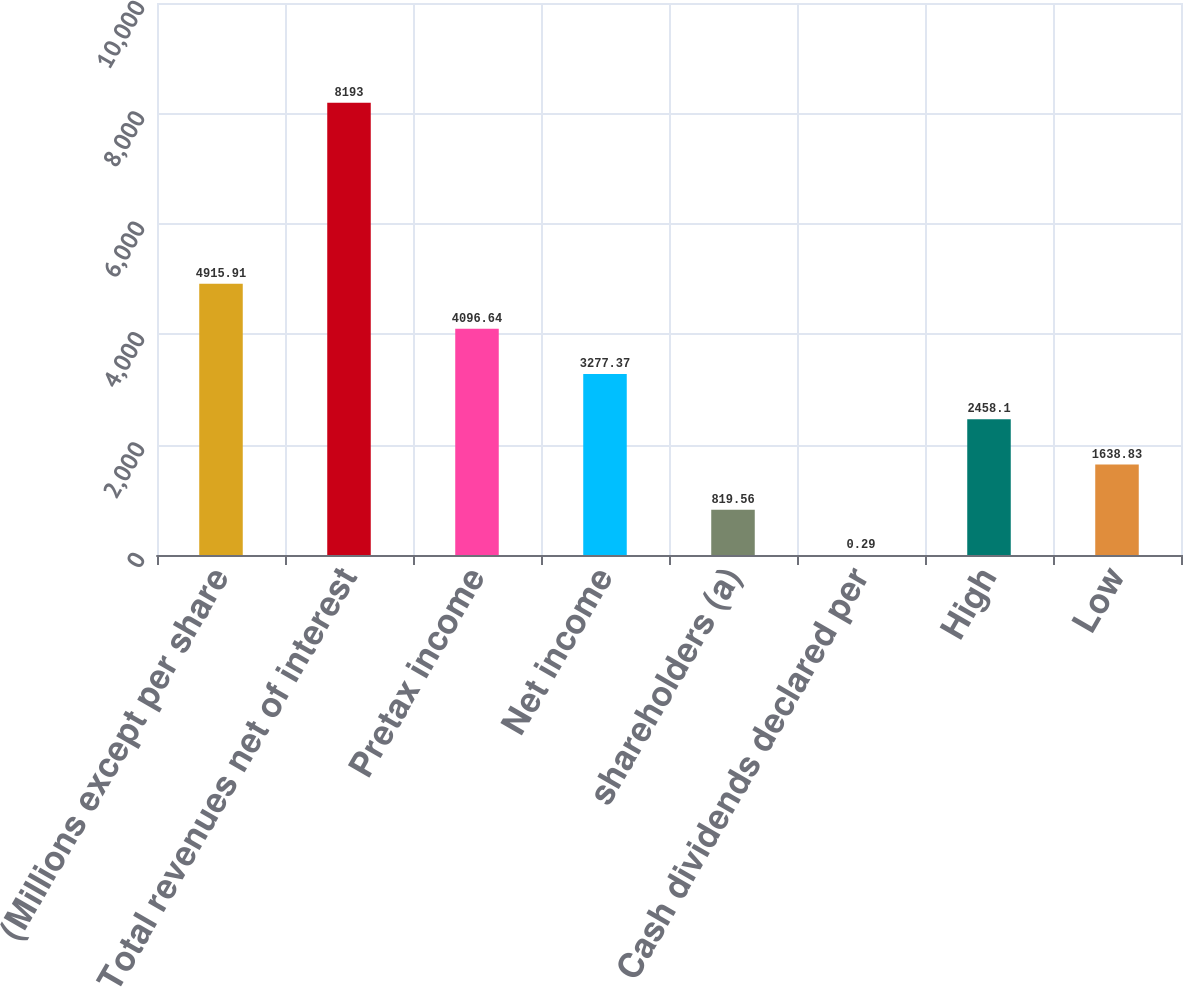<chart> <loc_0><loc_0><loc_500><loc_500><bar_chart><fcel>(Millions except per share<fcel>Total revenues net of interest<fcel>Pretax income<fcel>Net income<fcel>shareholders (a)<fcel>Cash dividends declared per<fcel>High<fcel>Low<nl><fcel>4915.91<fcel>8193<fcel>4096.64<fcel>3277.37<fcel>819.56<fcel>0.29<fcel>2458.1<fcel>1638.83<nl></chart> 